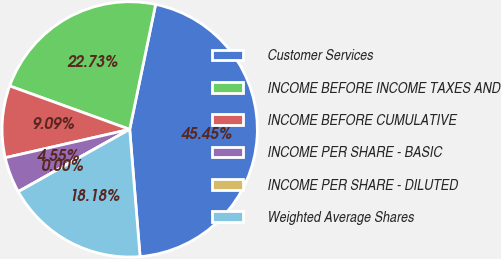<chart> <loc_0><loc_0><loc_500><loc_500><pie_chart><fcel>Customer Services<fcel>INCOME BEFORE INCOME TAXES AND<fcel>INCOME BEFORE CUMULATIVE<fcel>INCOME PER SHARE - BASIC<fcel>INCOME PER SHARE - DILUTED<fcel>Weighted Average Shares<nl><fcel>45.45%<fcel>22.73%<fcel>9.09%<fcel>4.55%<fcel>0.0%<fcel>18.18%<nl></chart> 